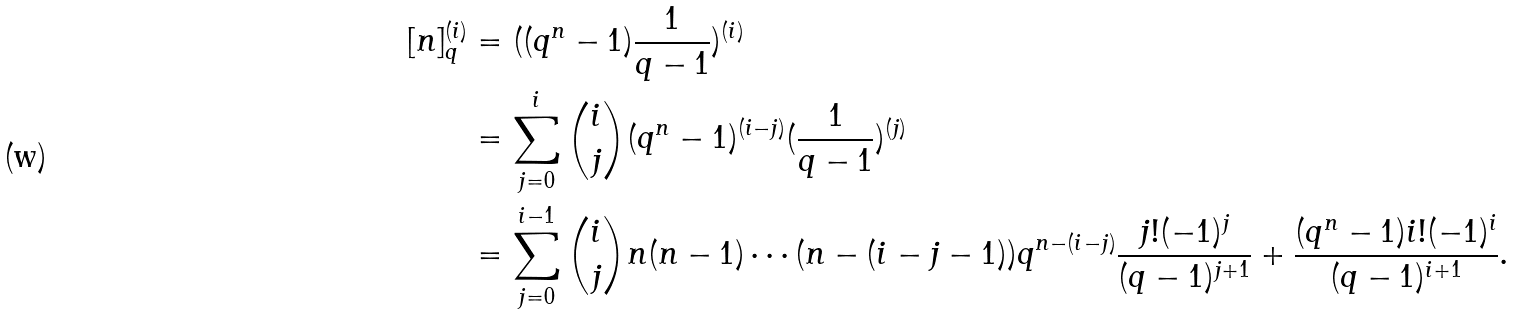Convert formula to latex. <formula><loc_0><loc_0><loc_500><loc_500>[ n ] _ { q } ^ { ( i ) } & = ( ( q ^ { n } - 1 ) \frac { 1 } { q - 1 } ) ^ { ( i ) } \\ & = \sum _ { j = 0 } ^ { i } \binom { i } { j } ( q ^ { n } - 1 ) ^ { ( i - j ) } ( \frac { 1 } { q - 1 } ) ^ { ( j ) } \\ & = \sum _ { j = 0 } ^ { i - 1 } \binom { i } { j } n ( n - 1 ) \cdots ( n - ( i - j - 1 ) ) q ^ { n - ( i - j ) } \frac { j ! ( - 1 ) ^ { j } } { ( q - 1 ) ^ { j + 1 } } + \frac { ( q ^ { n } - 1 ) i ! ( - 1 ) ^ { i } } { ( q - 1 ) ^ { i + 1 } } .</formula> 